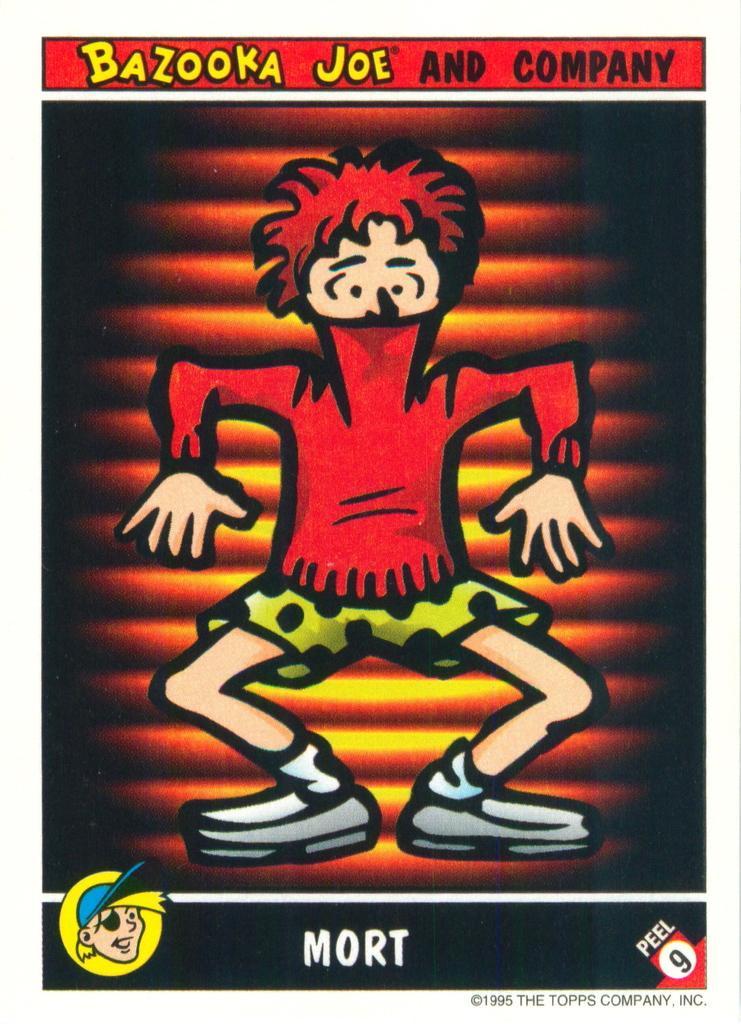In one or two sentences, can you explain what this image depicts? This is a poster in this image in the center there is one person, and at the top and bottom of the image there is some text. 